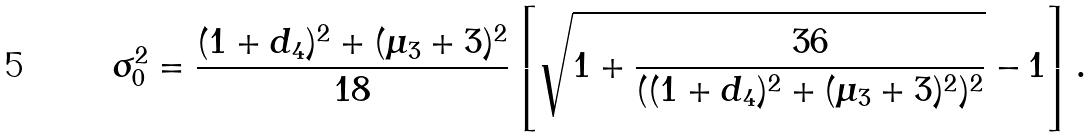Convert formula to latex. <formula><loc_0><loc_0><loc_500><loc_500>\sigma _ { 0 } ^ { 2 } = \frac { ( 1 + d _ { 4 } ) ^ { 2 } + ( \mu _ { 3 } + 3 ) ^ { 2 } } { 1 8 } \left [ \sqrt { 1 + \frac { 3 6 } { ( ( 1 + d _ { 4 } ) ^ { 2 } + ( \mu _ { 3 } + 3 ) ^ { 2 } ) ^ { 2 } } } - 1 \right ] .</formula> 